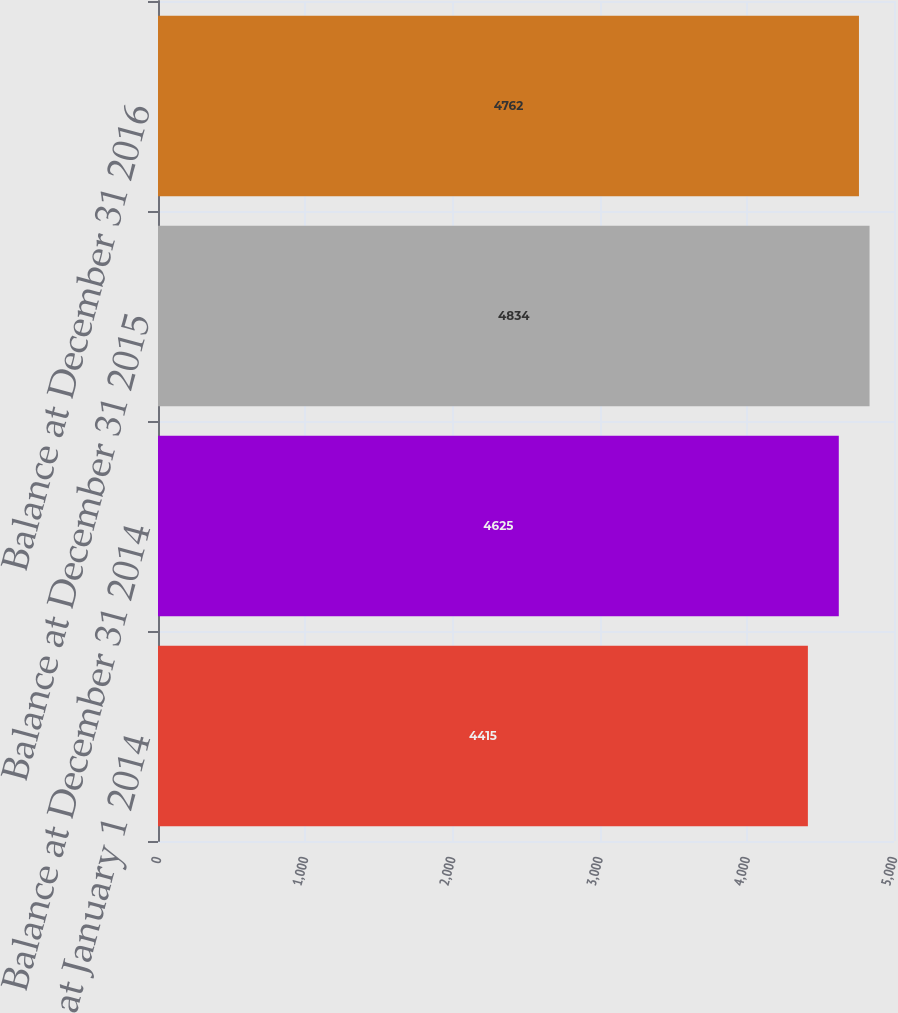Convert chart to OTSL. <chart><loc_0><loc_0><loc_500><loc_500><bar_chart><fcel>Balance at January 1 2014<fcel>Balance at December 31 2014<fcel>Balance at December 31 2015<fcel>Balance at December 31 2016<nl><fcel>4415<fcel>4625<fcel>4834<fcel>4762<nl></chart> 